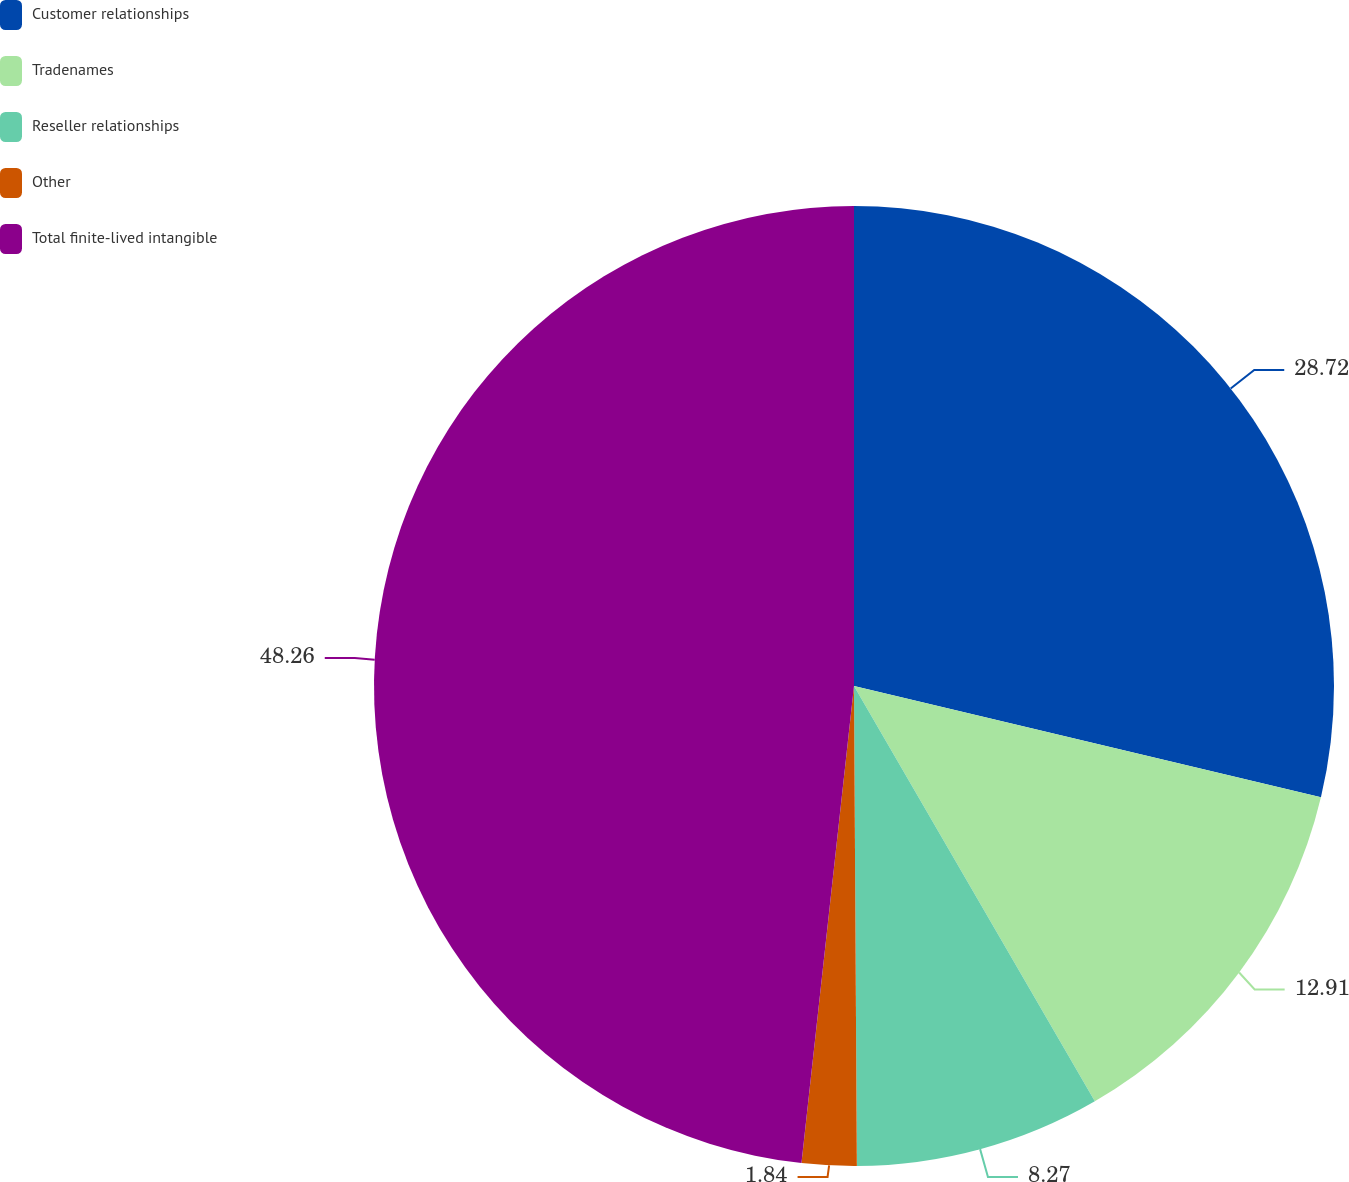Convert chart to OTSL. <chart><loc_0><loc_0><loc_500><loc_500><pie_chart><fcel>Customer relationships<fcel>Tradenames<fcel>Reseller relationships<fcel>Other<fcel>Total finite-lived intangible<nl><fcel>28.72%<fcel>12.91%<fcel>8.27%<fcel>1.84%<fcel>48.25%<nl></chart> 